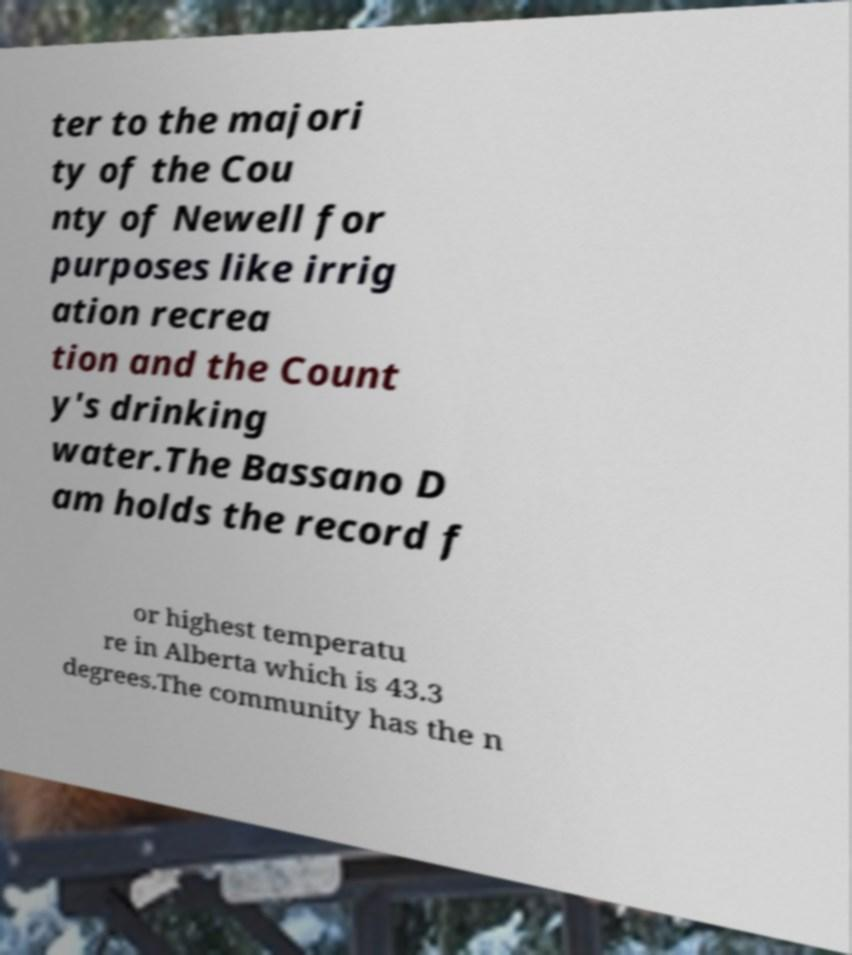Please read and relay the text visible in this image. What does it say? ter to the majori ty of the Cou nty of Newell for purposes like irrig ation recrea tion and the Count y's drinking water.The Bassano D am holds the record f or highest temperatu re in Alberta which is 43.3 degrees.The community has the n 